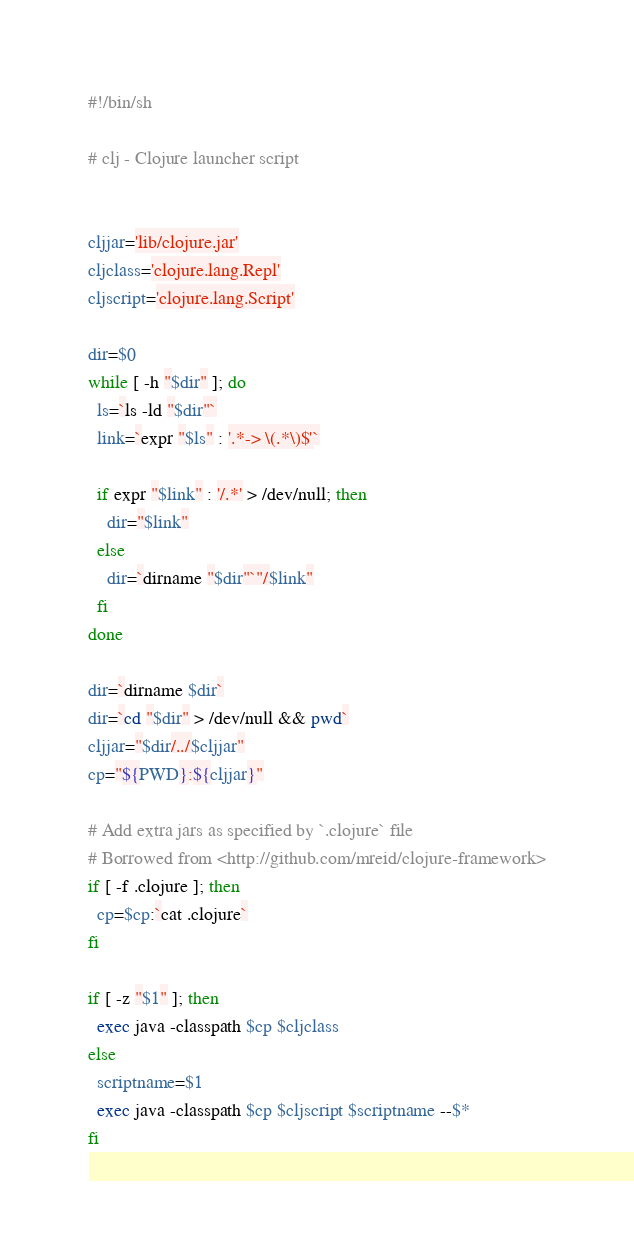<code> <loc_0><loc_0><loc_500><loc_500><_Bash_>#!/bin/sh

# clj - Clojure launcher script


cljjar='lib/clojure.jar'
cljclass='clojure.lang.Repl'
cljscript='clojure.lang.Script'

dir=$0
while [ -h "$dir" ]; do
  ls=`ls -ld "$dir"`
  link=`expr "$ls" : '.*-> \(.*\)$'`
  
  if expr "$link" : '/.*' > /dev/null; then
    dir="$link"
  else
    dir=`dirname "$dir"`"/$link"
  fi
done

dir=`dirname $dir`
dir=`cd "$dir" > /dev/null && pwd`
cljjar="$dir/../$cljjar"
cp="${PWD}:${cljjar}"

# Add extra jars as specified by `.clojure` file
# Borrowed from <http://github.com/mreid/clojure-framework>
if [ -f .clojure ]; then
  cp=$cp:`cat .clojure`
fi

if [ -z "$1" ]; then
  exec java -classpath $cp $cljclass
else
  scriptname=$1
  exec java -classpath $cp $cljscript $scriptname --$*
fi
</code> 